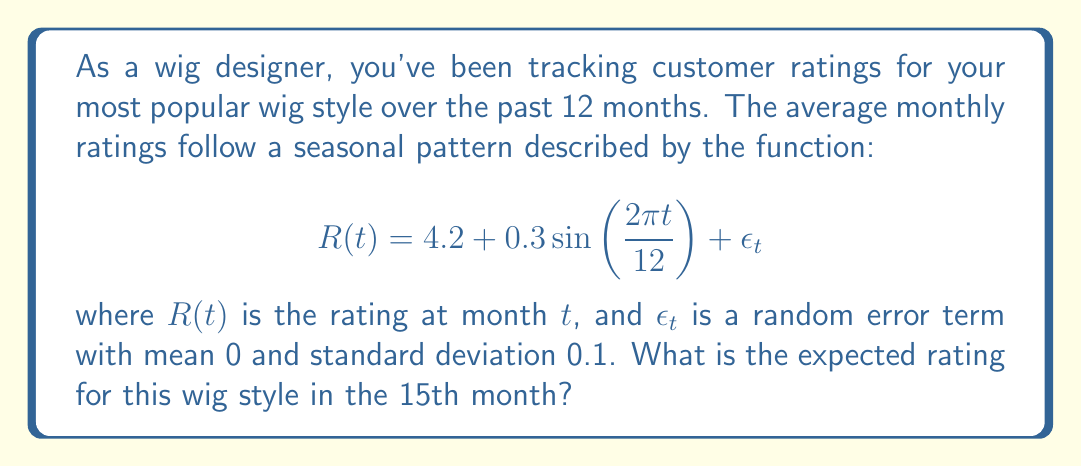Show me your answer to this math problem. To solve this problem, we need to understand and apply the given time series model:

1) The function $R(t)$ represents the rating at month $t$.

2) The model has three components:
   - A constant term: 4.2
   - A seasonal component: $0.3\sin\left(\frac{2\pi t}{12}\right)$
   - An error term: $\epsilon_t$

3) The seasonal component has a period of 12 months, which aligns with annual seasonality in wig ratings.

4) To find the expected rating, we ignore the error term $\epsilon_t$ as its expected value is 0.

5) We need to calculate the value for $t = 15$:

   $$R(15) = 4.2 + 0.3\sin\left(\frac{2\pi \cdot 15}{12}\right)$$

6) Simplify the argument of sine:
   $$\frac{2\pi \cdot 15}{12} = \frac{5\pi}{2} = 2\pi + \frac{\pi}{2}$$

7) Recall that $\sin(2\pi + \frac{\pi}{2}) = \sin(\frac{\pi}{2}) = 1$

8) Therefore:
   $$R(15) = 4.2 + 0.3 \cdot 1 = 4.2 + 0.3 = 4.5$$

Thus, the expected rating for the 15th month is 4.5.
Answer: 4.5 